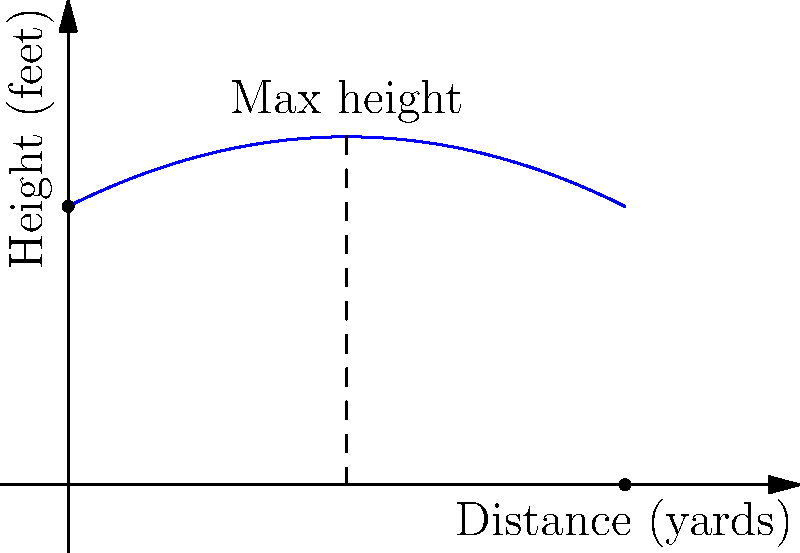A football is thrown in an arc that can be modeled by the function $h(x) = -0.025x^2 + 0.5x + 10$, where $h$ is the height in feet and $x$ is the horizontal distance in yards. What is the maximum height reached by the football, and at what distance from the throw does this occur? To find the maximum height and its corresponding distance, we need to follow these steps:

1) The maximum point of a quadratic function occurs at the vertex of the parabola.

2) For a quadratic function in the form $f(x) = ax^2 + bx + c$, the x-coordinate of the vertex is given by $x = -\frac{b}{2a}$.

3) In our function $h(x) = -0.025x^2 + 0.5x + 10$:
   $a = -0.025$
   $b = 0.5$
   $c = 10$

4) Calculating the x-coordinate of the vertex:
   $x = -\frac{0.5}{2(-0.025)} = -\frac{0.5}{-0.05} = 10$ yards

5) To find the maximum height, we substitute this x-value back into the original function:
   $h(10) = -0.025(10)^2 + 0.5(10) + 10$
          $= -0.025(100) + 5 + 10$
          $= -2.5 + 5 + 10$
          $= 12.5$ feet

Therefore, the maximum height reached is 12.5 feet, occurring at a distance of 10 yards from the throw.
Answer: 12.5 feet at 10 yards 